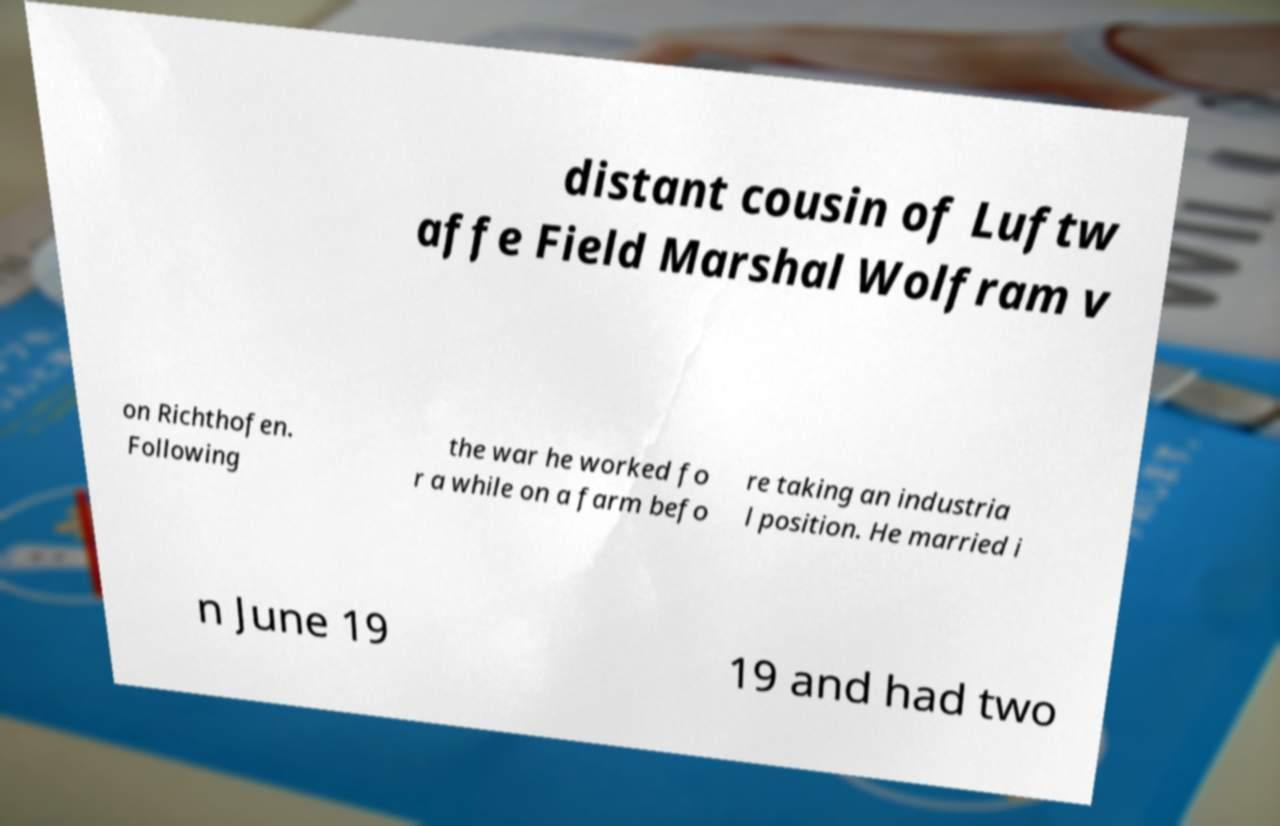Can you read and provide the text displayed in the image?This photo seems to have some interesting text. Can you extract and type it out for me? distant cousin of Luftw affe Field Marshal Wolfram v on Richthofen. Following the war he worked fo r a while on a farm befo re taking an industria l position. He married i n June 19 19 and had two 